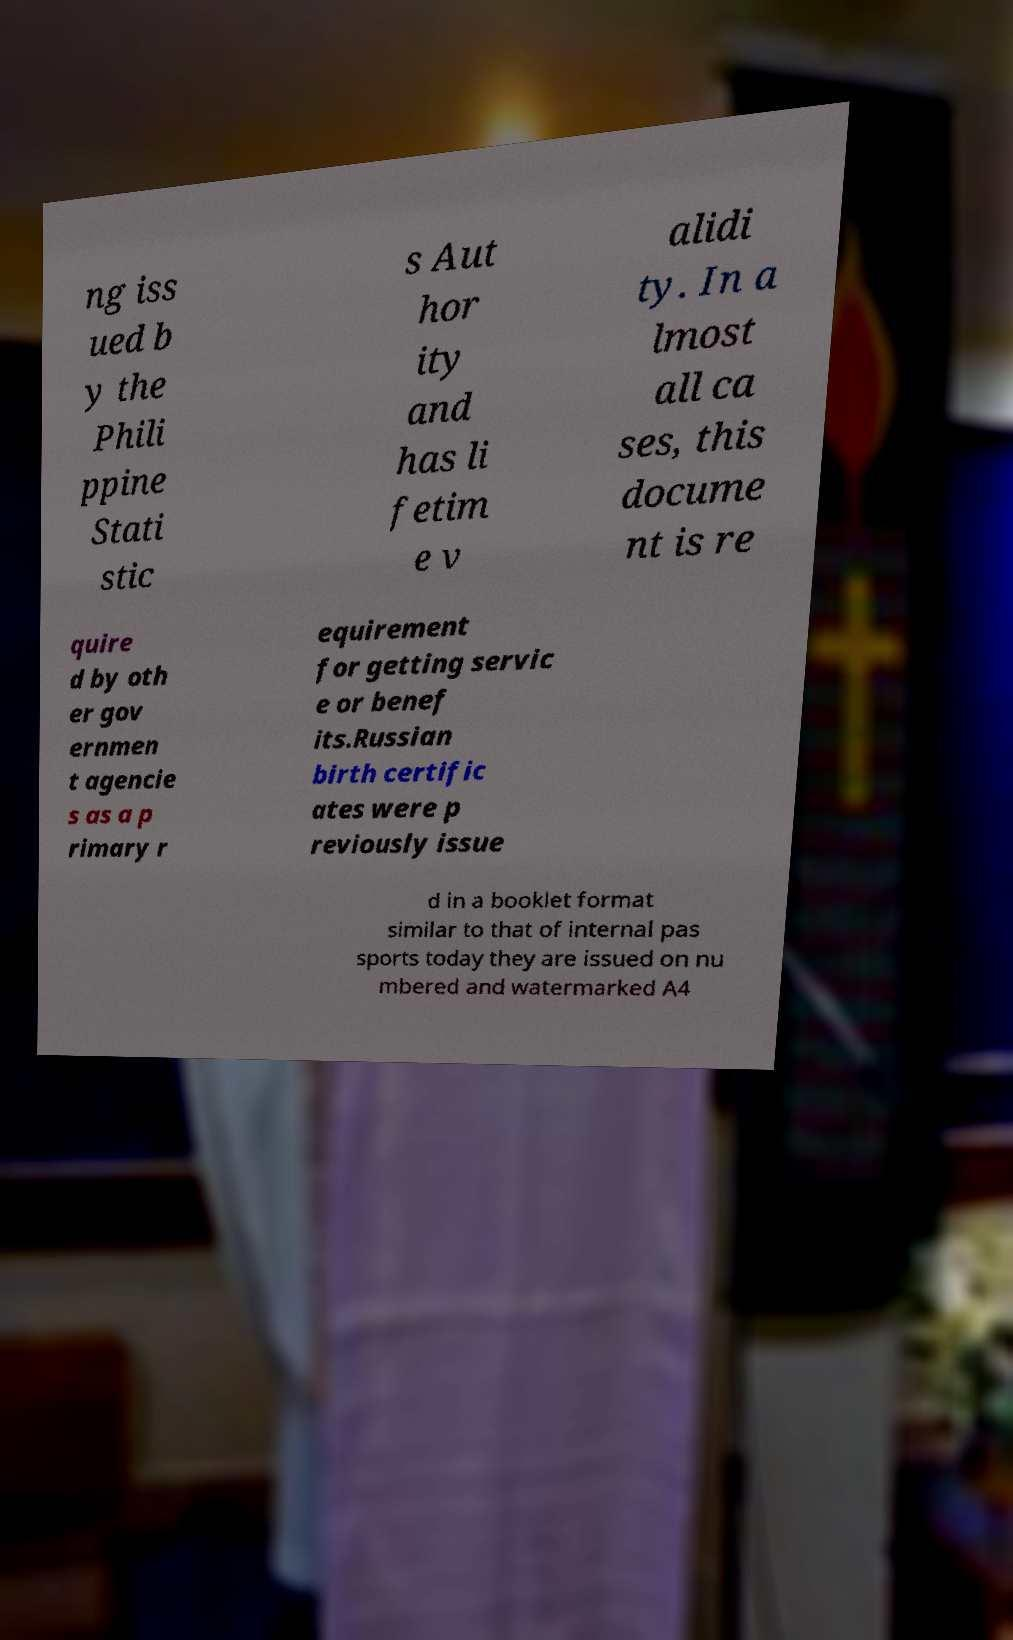Can you read and provide the text displayed in the image?This photo seems to have some interesting text. Can you extract and type it out for me? ng iss ued b y the Phili ppine Stati stic s Aut hor ity and has li fetim e v alidi ty. In a lmost all ca ses, this docume nt is re quire d by oth er gov ernmen t agencie s as a p rimary r equirement for getting servic e or benef its.Russian birth certific ates were p reviously issue d in a booklet format similar to that of internal pas sports today they are issued on nu mbered and watermarked A4 